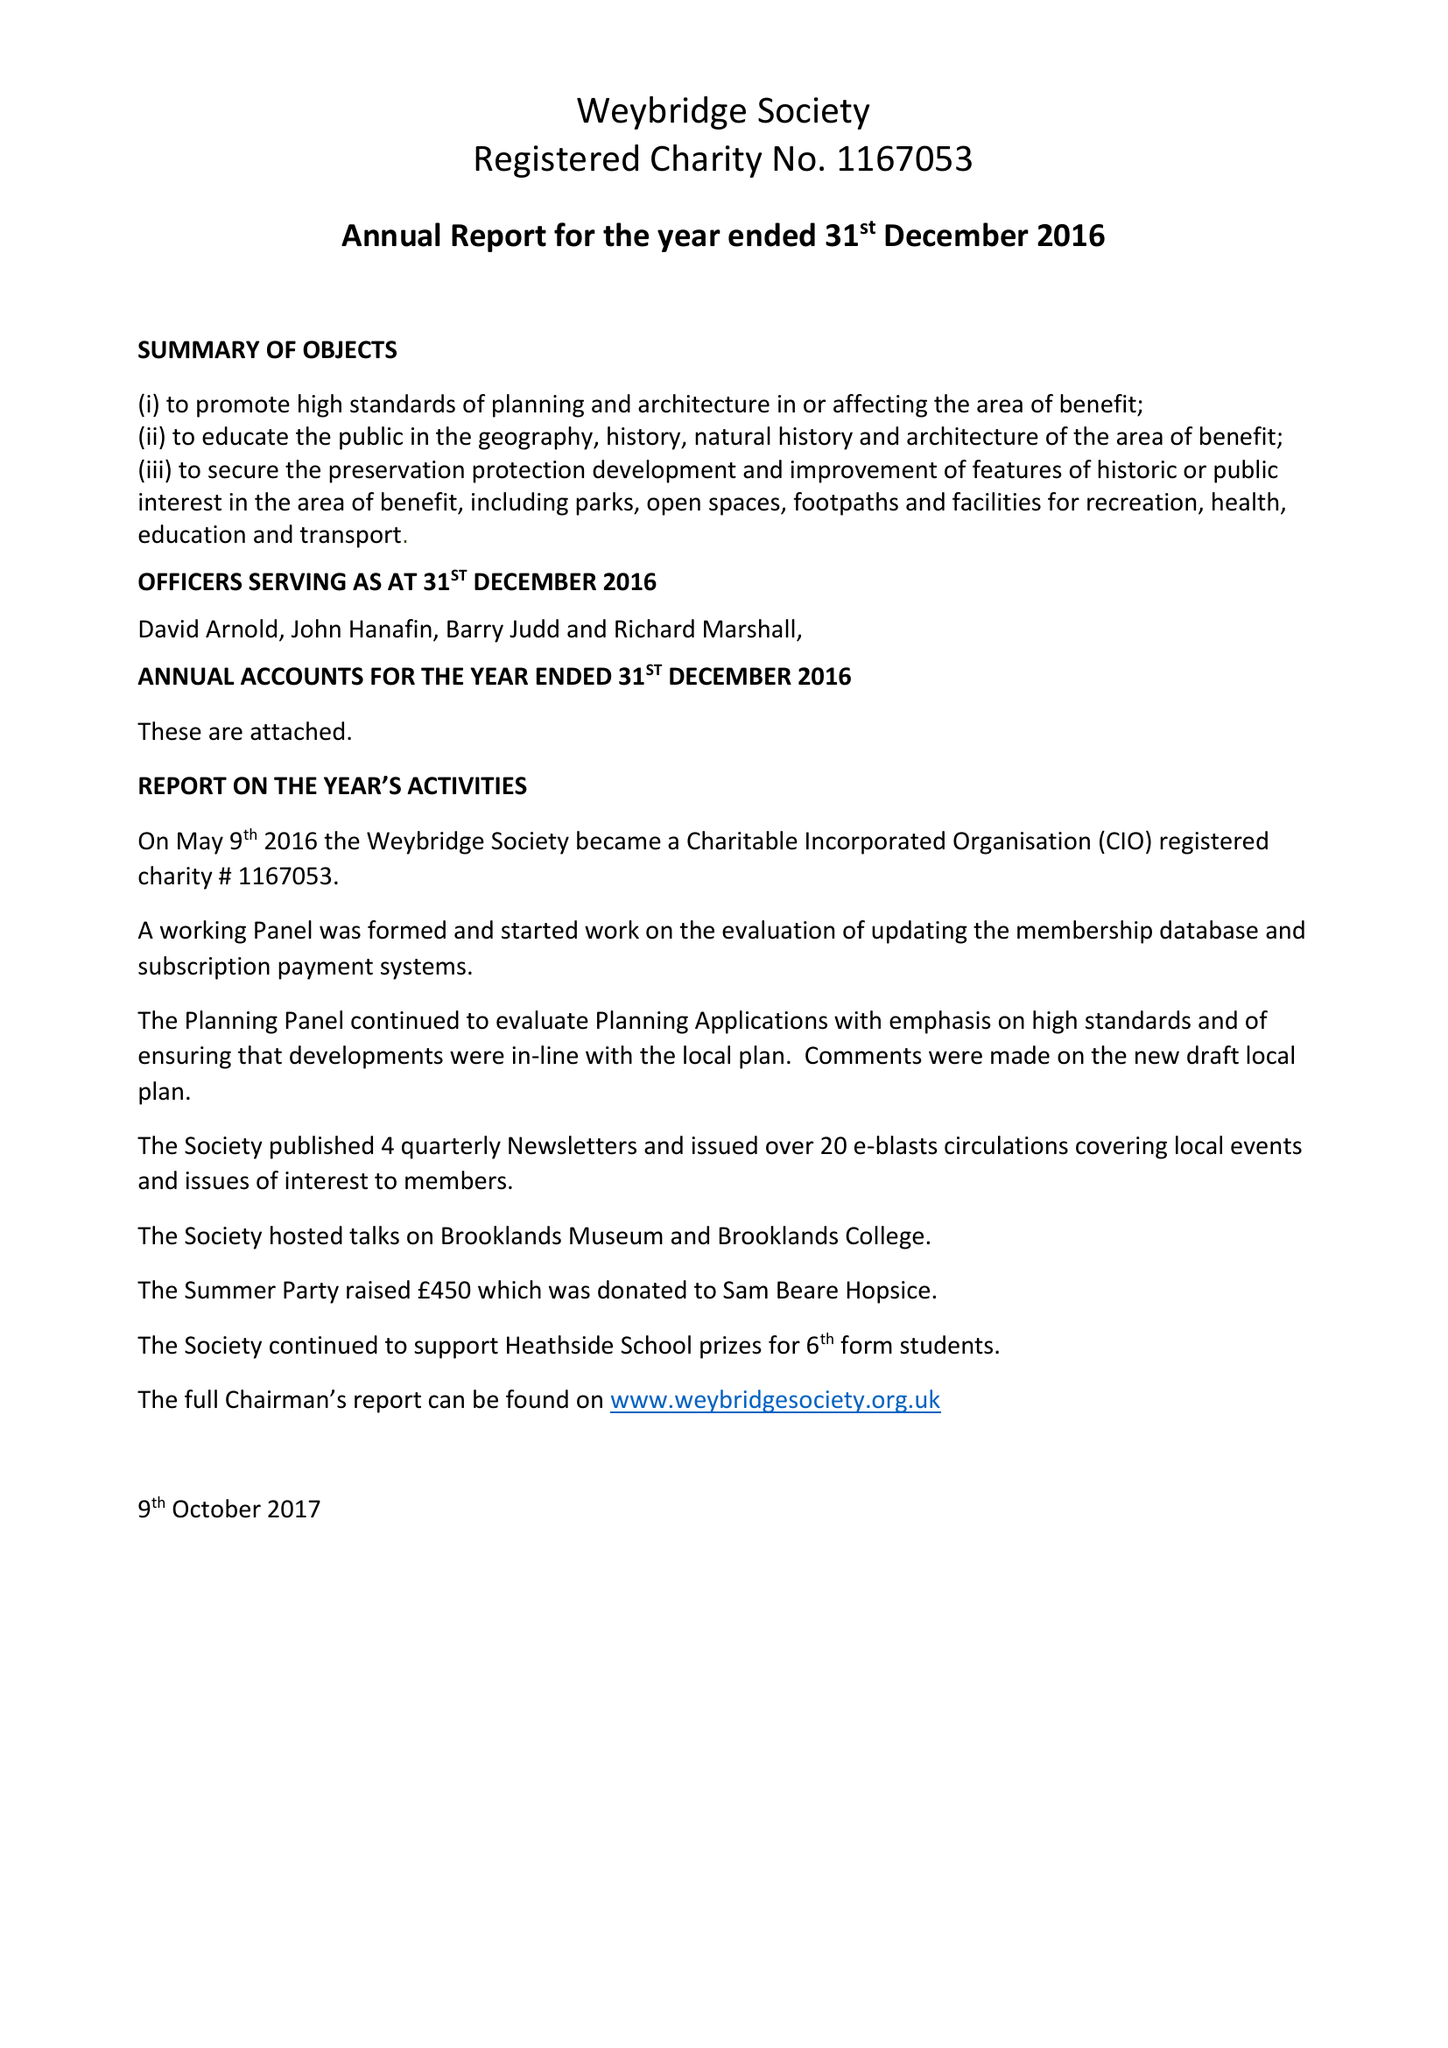What is the value for the income_annually_in_british_pounds?
Answer the question using a single word or phrase. 4540.00 